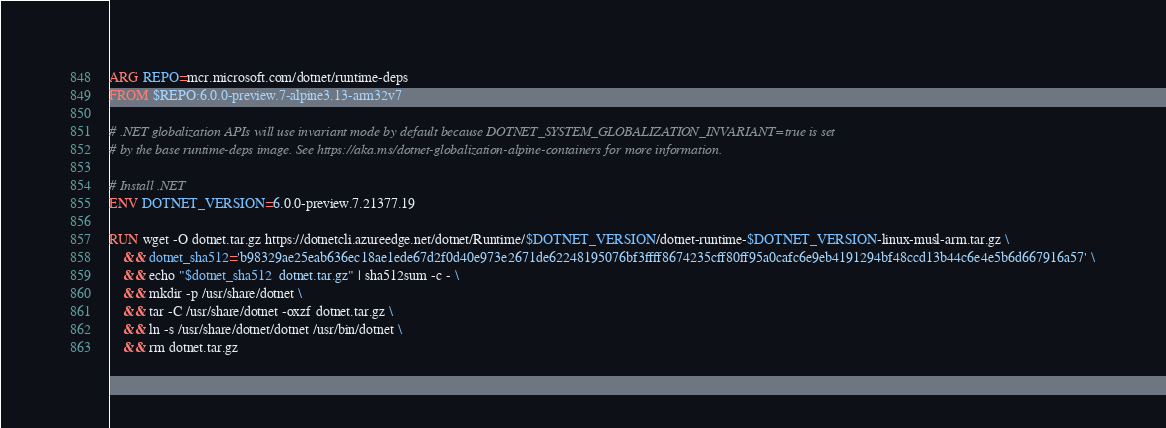<code> <loc_0><loc_0><loc_500><loc_500><_Dockerfile_>ARG REPO=mcr.microsoft.com/dotnet/runtime-deps
FROM $REPO:6.0.0-preview.7-alpine3.13-arm32v7

# .NET globalization APIs will use invariant mode by default because DOTNET_SYSTEM_GLOBALIZATION_INVARIANT=true is set
# by the base runtime-deps image. See https://aka.ms/dotnet-globalization-alpine-containers for more information.

# Install .NET
ENV DOTNET_VERSION=6.0.0-preview.7.21377.19

RUN wget -O dotnet.tar.gz https://dotnetcli.azureedge.net/dotnet/Runtime/$DOTNET_VERSION/dotnet-runtime-$DOTNET_VERSION-linux-musl-arm.tar.gz \
    && dotnet_sha512='b98329ae25eab636ec18ae1ede67d2f0d40e973e2671de62248195076bf3ffff8674235cff80ff95a0cafc6e9eb4191294bf48ccd13b44c6e4e5b6d667916a57' \
    && echo "$dotnet_sha512  dotnet.tar.gz" | sha512sum -c - \
    && mkdir -p /usr/share/dotnet \
    && tar -C /usr/share/dotnet -oxzf dotnet.tar.gz \
    && ln -s /usr/share/dotnet/dotnet /usr/bin/dotnet \
    && rm dotnet.tar.gz
</code> 